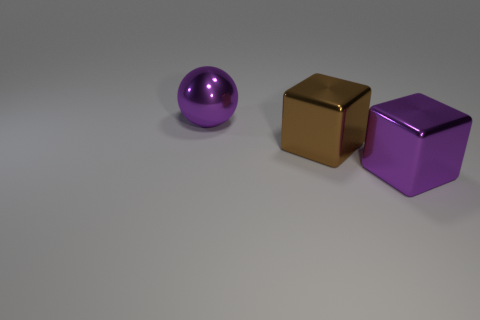Subtract all purple blocks. How many blocks are left? 1 Subtract 2 cubes. How many cubes are left? 0 Add 2 purple blocks. How many objects exist? 5 Subtract all balls. How many objects are left? 2 Add 3 purple metallic cubes. How many purple metallic cubes are left? 4 Add 1 large purple shiny objects. How many large purple shiny objects exist? 3 Subtract 0 blue balls. How many objects are left? 3 Subtract all gray cubes. Subtract all brown spheres. How many cubes are left? 2 Subtract all gray cylinders. How many purple blocks are left? 1 Subtract all large matte objects. Subtract all large metal objects. How many objects are left? 0 